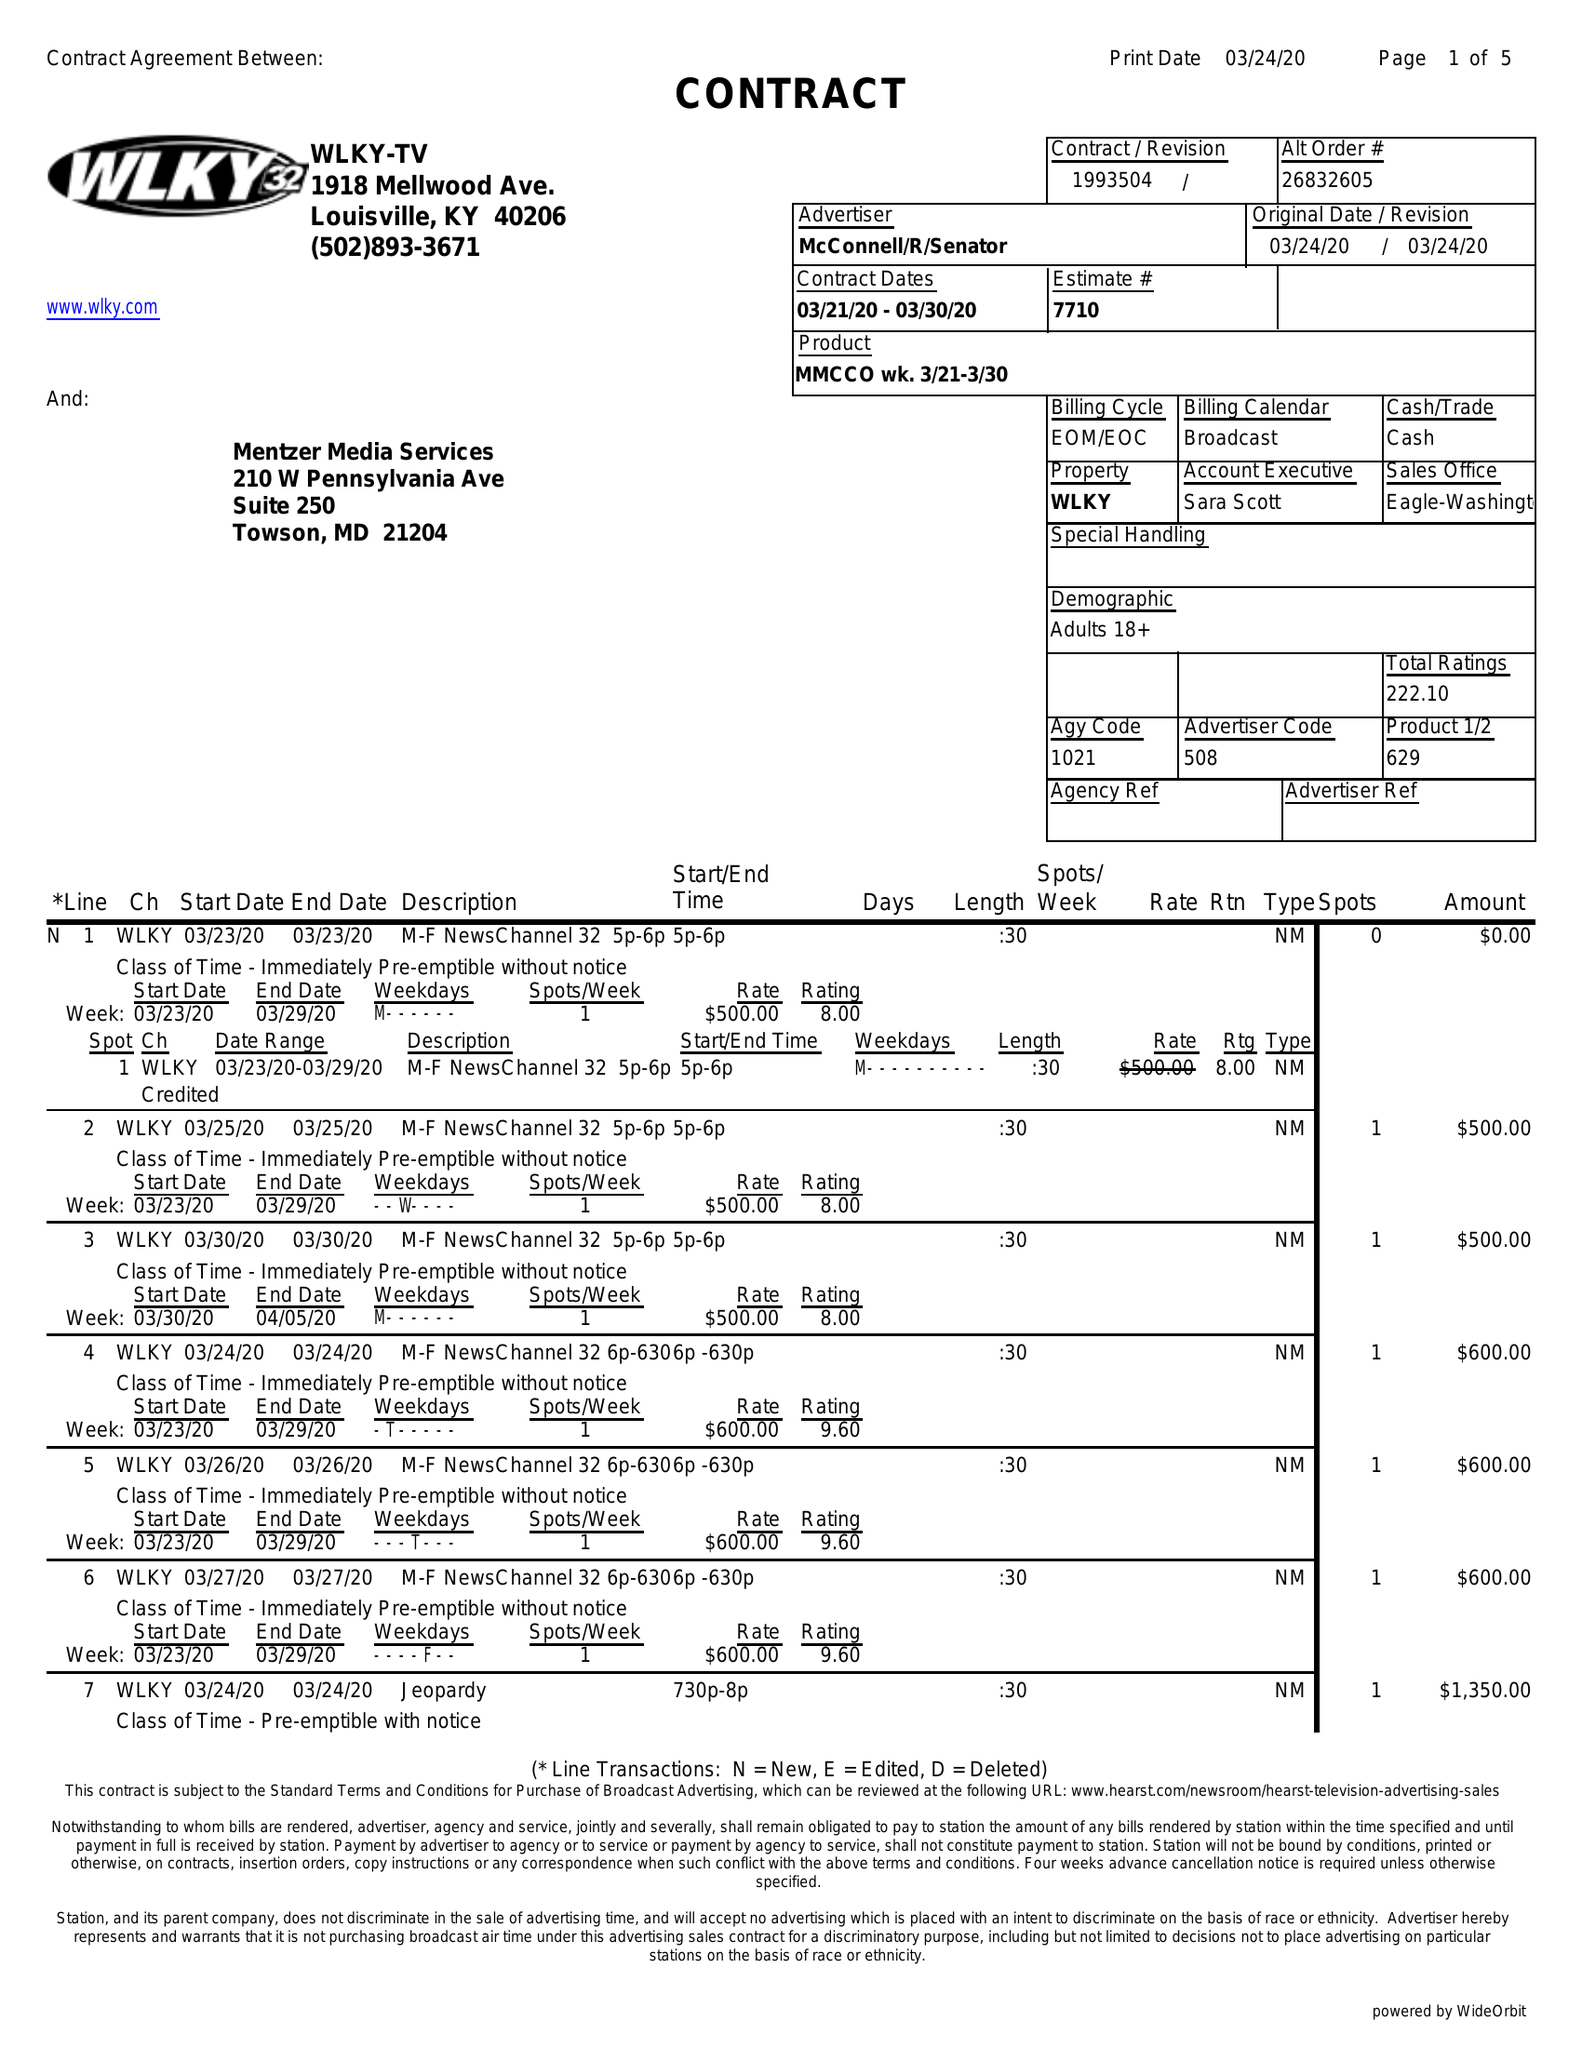What is the value for the flight_from?
Answer the question using a single word or phrase. 03/21/20 